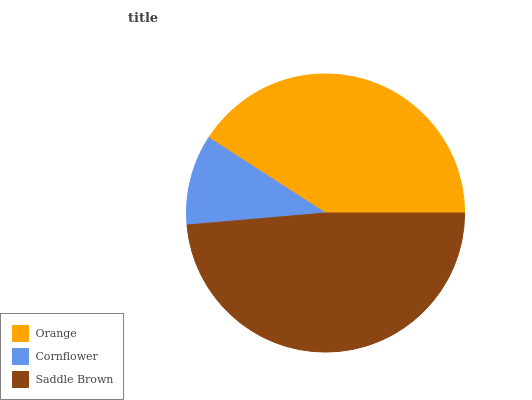Is Cornflower the minimum?
Answer yes or no. Yes. Is Saddle Brown the maximum?
Answer yes or no. Yes. Is Saddle Brown the minimum?
Answer yes or no. No. Is Cornflower the maximum?
Answer yes or no. No. Is Saddle Brown greater than Cornflower?
Answer yes or no. Yes. Is Cornflower less than Saddle Brown?
Answer yes or no. Yes. Is Cornflower greater than Saddle Brown?
Answer yes or no. No. Is Saddle Brown less than Cornflower?
Answer yes or no. No. Is Orange the high median?
Answer yes or no. Yes. Is Orange the low median?
Answer yes or no. Yes. Is Saddle Brown the high median?
Answer yes or no. No. Is Saddle Brown the low median?
Answer yes or no. No. 